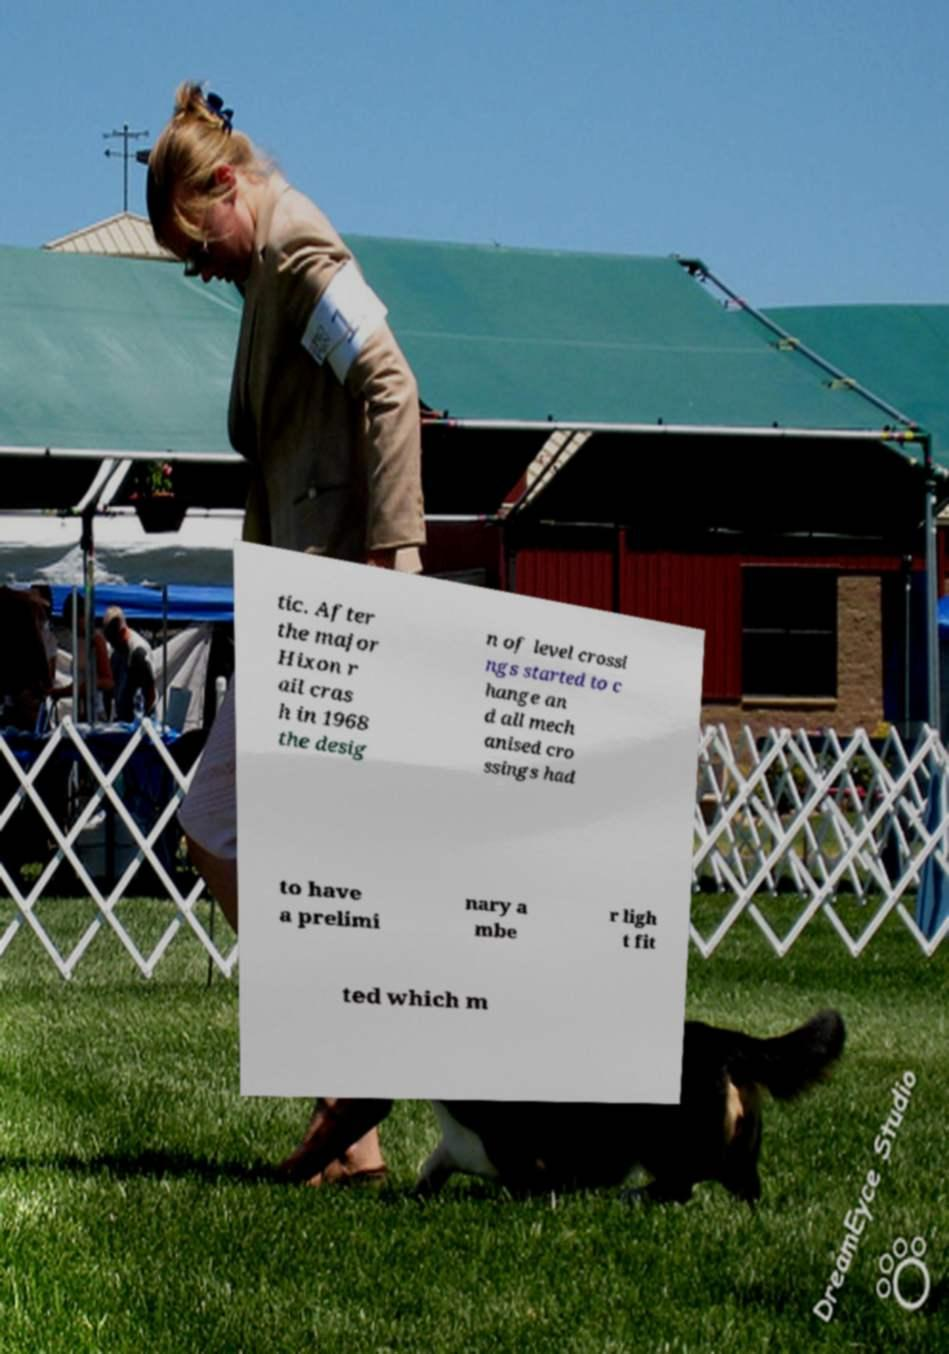For documentation purposes, I need the text within this image transcribed. Could you provide that? tic. After the major Hixon r ail cras h in 1968 the desig n of level crossi ngs started to c hange an d all mech anised cro ssings had to have a prelimi nary a mbe r ligh t fit ted which m 